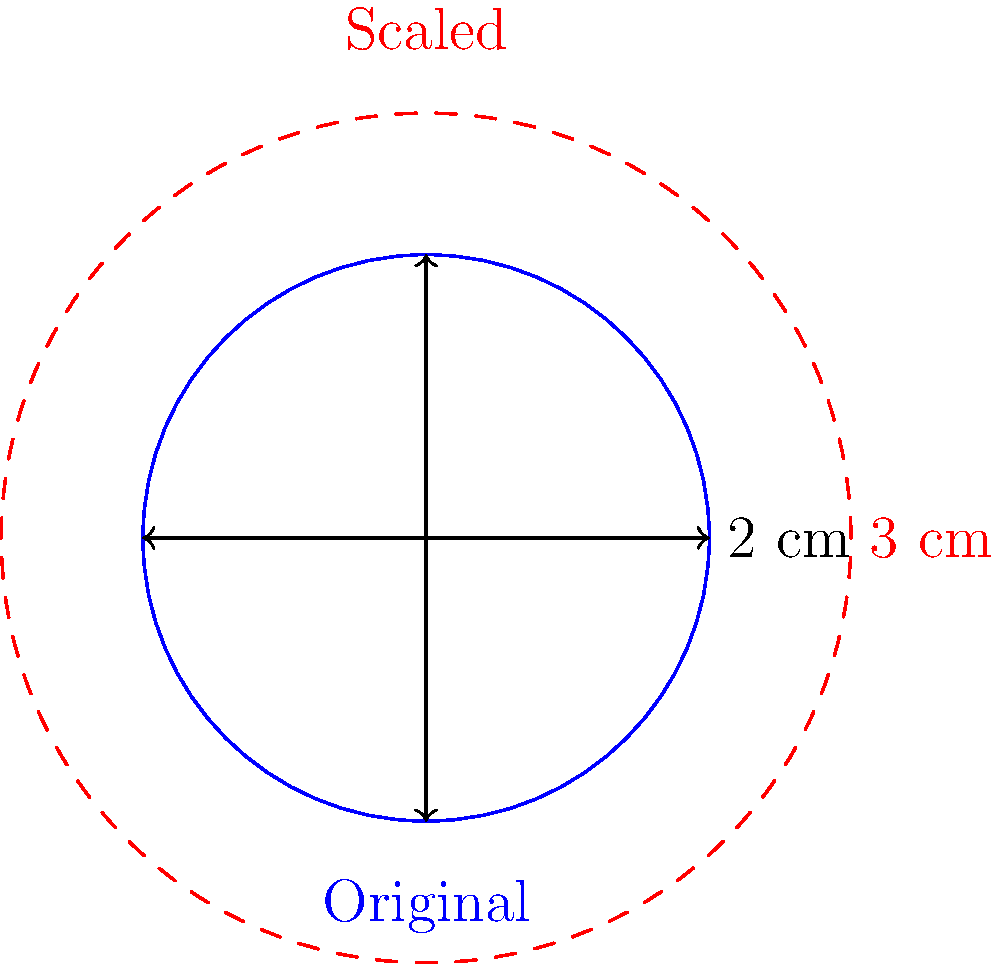A damaged piston from a salvaged engine has been assessed for potential reuse. The original piston diameter is 2 cm. To fit into a larger engine, the piston needs to be scaled up by a factor of 1.5. Calculate the new surface area of the piston head after scaling. Round your answer to two decimal places. To solve this problem, we'll follow these steps:

1. Calculate the radius of the original piston:
   Diameter = 2 cm, so radius = 1 cm

2. Calculate the original surface area:
   $A_{original} = \pi r^2 = \pi (1 \text{ cm})^2 = \pi \text{ cm}^2$

3. Apply the scaling factor:
   The piston is scaled by a factor of 1.5 in each dimension.
   For area, we need to square this factor: $(1.5)^2 = 2.25$

4. Calculate the new surface area:
   $A_{new} = 2.25 \times A_{original} = 2.25 \pi \text{ cm}^2$

5. Substitute $\pi \approx 3.14159$ and calculate:
   $A_{new} \approx 2.25 \times 3.14159 \text{ cm}^2 = 7.06858 \text{ cm}^2$

6. Round to two decimal places:
   $A_{new} \approx 7.07 \text{ cm}^2$
Answer: $7.07 \text{ cm}^2$ 